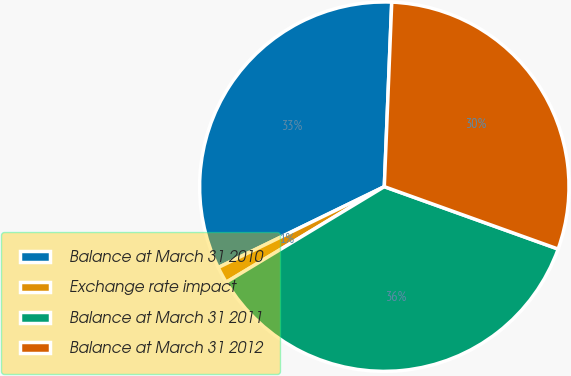Convert chart to OTSL. <chart><loc_0><loc_0><loc_500><loc_500><pie_chart><fcel>Balance at March 31 2010<fcel>Exchange rate impact<fcel>Balance at March 31 2011<fcel>Balance at March 31 2012<nl><fcel>32.85%<fcel>1.44%<fcel>35.86%<fcel>29.84%<nl></chart> 